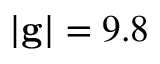<formula> <loc_0><loc_0><loc_500><loc_500>| g | = 9 . 8</formula> 